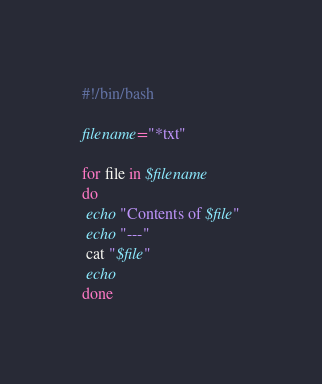<code> <loc_0><loc_0><loc_500><loc_500><_Bash_>#!/bin/bash

filename="*txt"

for file in $filename
do
 echo "Contents of $file"
 echo "---"
 cat "$file"
 echo
done
</code> 